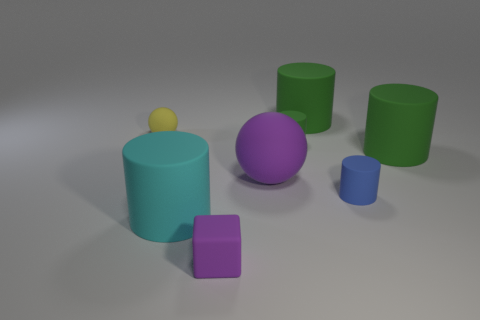Does the matte block have the same color as the large ball?
Keep it short and to the point. Yes. The other object that is the same shape as the small yellow thing is what size?
Your response must be concise. Large. Are there fewer tiny green cubes than green rubber objects?
Give a very brief answer. Yes. There is a green rubber thing that is behind the sphere to the left of the cyan object; what shape is it?
Offer a terse response. Cylinder. What is the shape of the purple thing that is in front of the cyan object that is in front of the big green object in front of the small green rubber cylinder?
Provide a short and direct response. Cube. What number of objects are either purple matte things that are in front of the large cyan cylinder or tiny matte objects behind the cyan cylinder?
Provide a succinct answer. 4. Is the size of the purple matte block the same as the rubber ball left of the small purple thing?
Make the answer very short. Yes. Are there the same number of cylinders on the left side of the yellow rubber sphere and tiny purple matte blocks to the right of the cyan cylinder?
Provide a short and direct response. No. What number of balls are the same color as the block?
Keep it short and to the point. 1. There is a tiny thing that is the same color as the big sphere; what is its material?
Ensure brevity in your answer.  Rubber. 